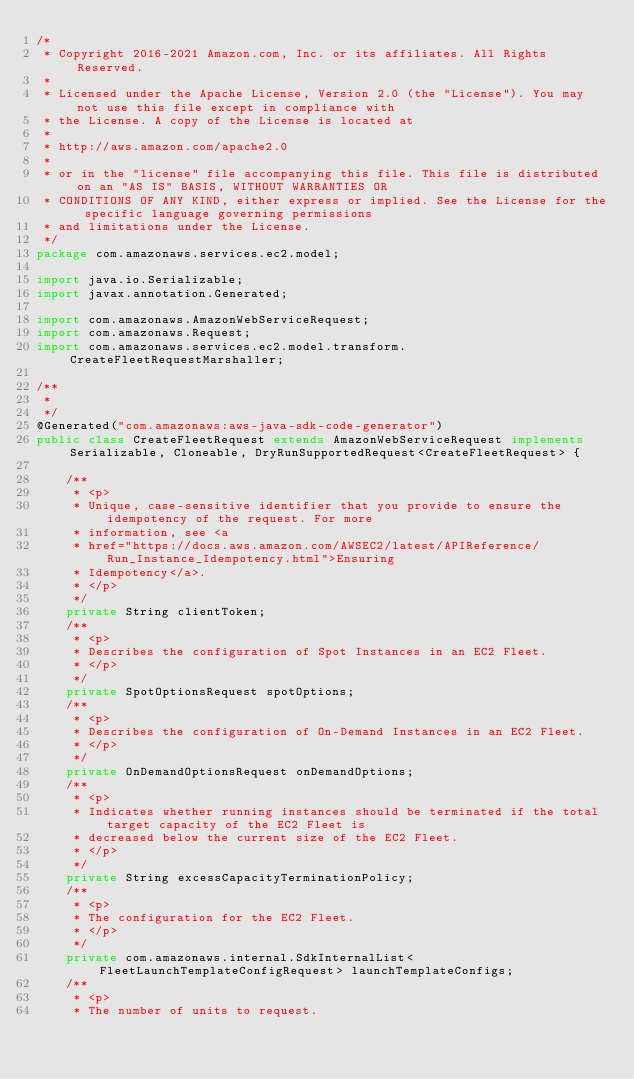Convert code to text. <code><loc_0><loc_0><loc_500><loc_500><_Java_>/*
 * Copyright 2016-2021 Amazon.com, Inc. or its affiliates. All Rights Reserved.
 * 
 * Licensed under the Apache License, Version 2.0 (the "License"). You may not use this file except in compliance with
 * the License. A copy of the License is located at
 * 
 * http://aws.amazon.com/apache2.0
 * 
 * or in the "license" file accompanying this file. This file is distributed on an "AS IS" BASIS, WITHOUT WARRANTIES OR
 * CONDITIONS OF ANY KIND, either express or implied. See the License for the specific language governing permissions
 * and limitations under the License.
 */
package com.amazonaws.services.ec2.model;

import java.io.Serializable;
import javax.annotation.Generated;

import com.amazonaws.AmazonWebServiceRequest;
import com.amazonaws.Request;
import com.amazonaws.services.ec2.model.transform.CreateFleetRequestMarshaller;

/**
 * 
 */
@Generated("com.amazonaws:aws-java-sdk-code-generator")
public class CreateFleetRequest extends AmazonWebServiceRequest implements Serializable, Cloneable, DryRunSupportedRequest<CreateFleetRequest> {

    /**
     * <p>
     * Unique, case-sensitive identifier that you provide to ensure the idempotency of the request. For more
     * information, see <a
     * href="https://docs.aws.amazon.com/AWSEC2/latest/APIReference/Run_Instance_Idempotency.html">Ensuring
     * Idempotency</a>.
     * </p>
     */
    private String clientToken;
    /**
     * <p>
     * Describes the configuration of Spot Instances in an EC2 Fleet.
     * </p>
     */
    private SpotOptionsRequest spotOptions;
    /**
     * <p>
     * Describes the configuration of On-Demand Instances in an EC2 Fleet.
     * </p>
     */
    private OnDemandOptionsRequest onDemandOptions;
    /**
     * <p>
     * Indicates whether running instances should be terminated if the total target capacity of the EC2 Fleet is
     * decreased below the current size of the EC2 Fleet.
     * </p>
     */
    private String excessCapacityTerminationPolicy;
    /**
     * <p>
     * The configuration for the EC2 Fleet.
     * </p>
     */
    private com.amazonaws.internal.SdkInternalList<FleetLaunchTemplateConfigRequest> launchTemplateConfigs;
    /**
     * <p>
     * The number of units to request.</code> 